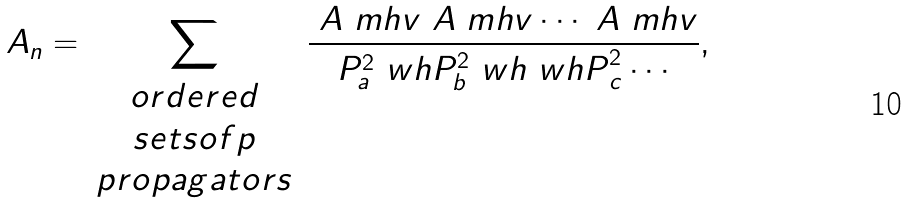<formula> <loc_0><loc_0><loc_500><loc_500>\ A _ { n } = \sum _ { \begin{array} { c } o r d e r e d \\ s e t s o f p \\ p r o p a g a t o r s \end{array} } \frac { \ A ^ { \ } m h v \ A ^ { \ } m h v \cdots \ A ^ { \ } m h v } { P _ { a } ^ { 2 } \ w h P _ { b } ^ { 2 } \ w h { \ w h P } _ { c } ^ { 2 } \cdots } ,</formula> 